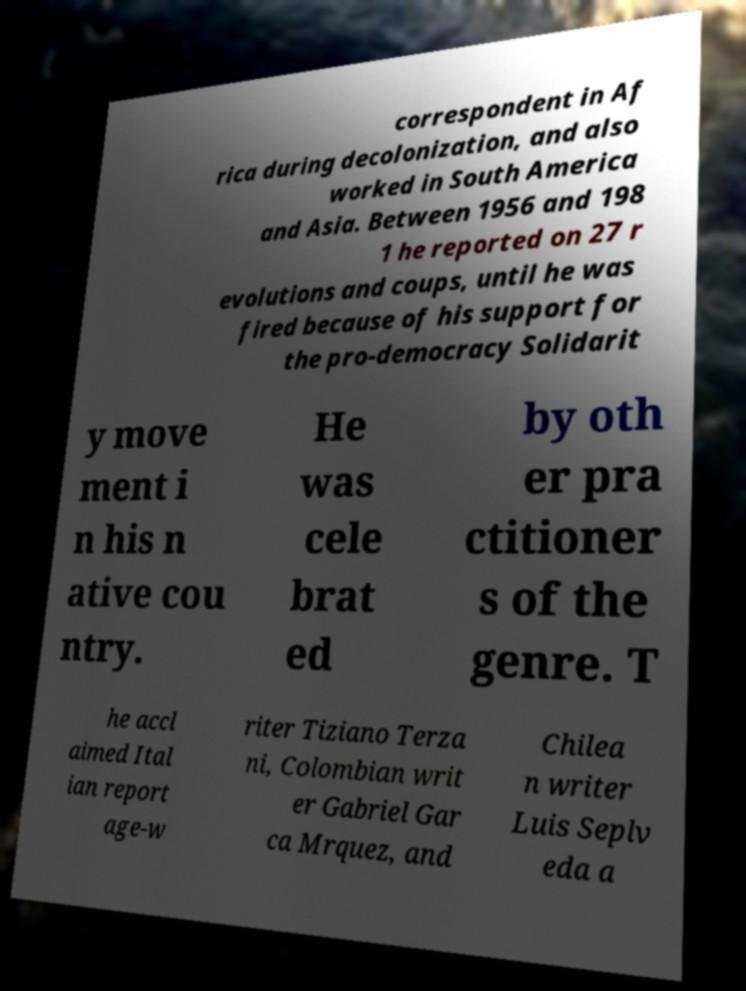Can you read and provide the text displayed in the image?This photo seems to have some interesting text. Can you extract and type it out for me? correspondent in Af rica during decolonization, and also worked in South America and Asia. Between 1956 and 198 1 he reported on 27 r evolutions and coups, until he was fired because of his support for the pro-democracy Solidarit y move ment i n his n ative cou ntry. He was cele brat ed by oth er pra ctitioner s of the genre. T he accl aimed Ital ian report age-w riter Tiziano Terza ni, Colombian writ er Gabriel Gar ca Mrquez, and Chilea n writer Luis Seplv eda a 